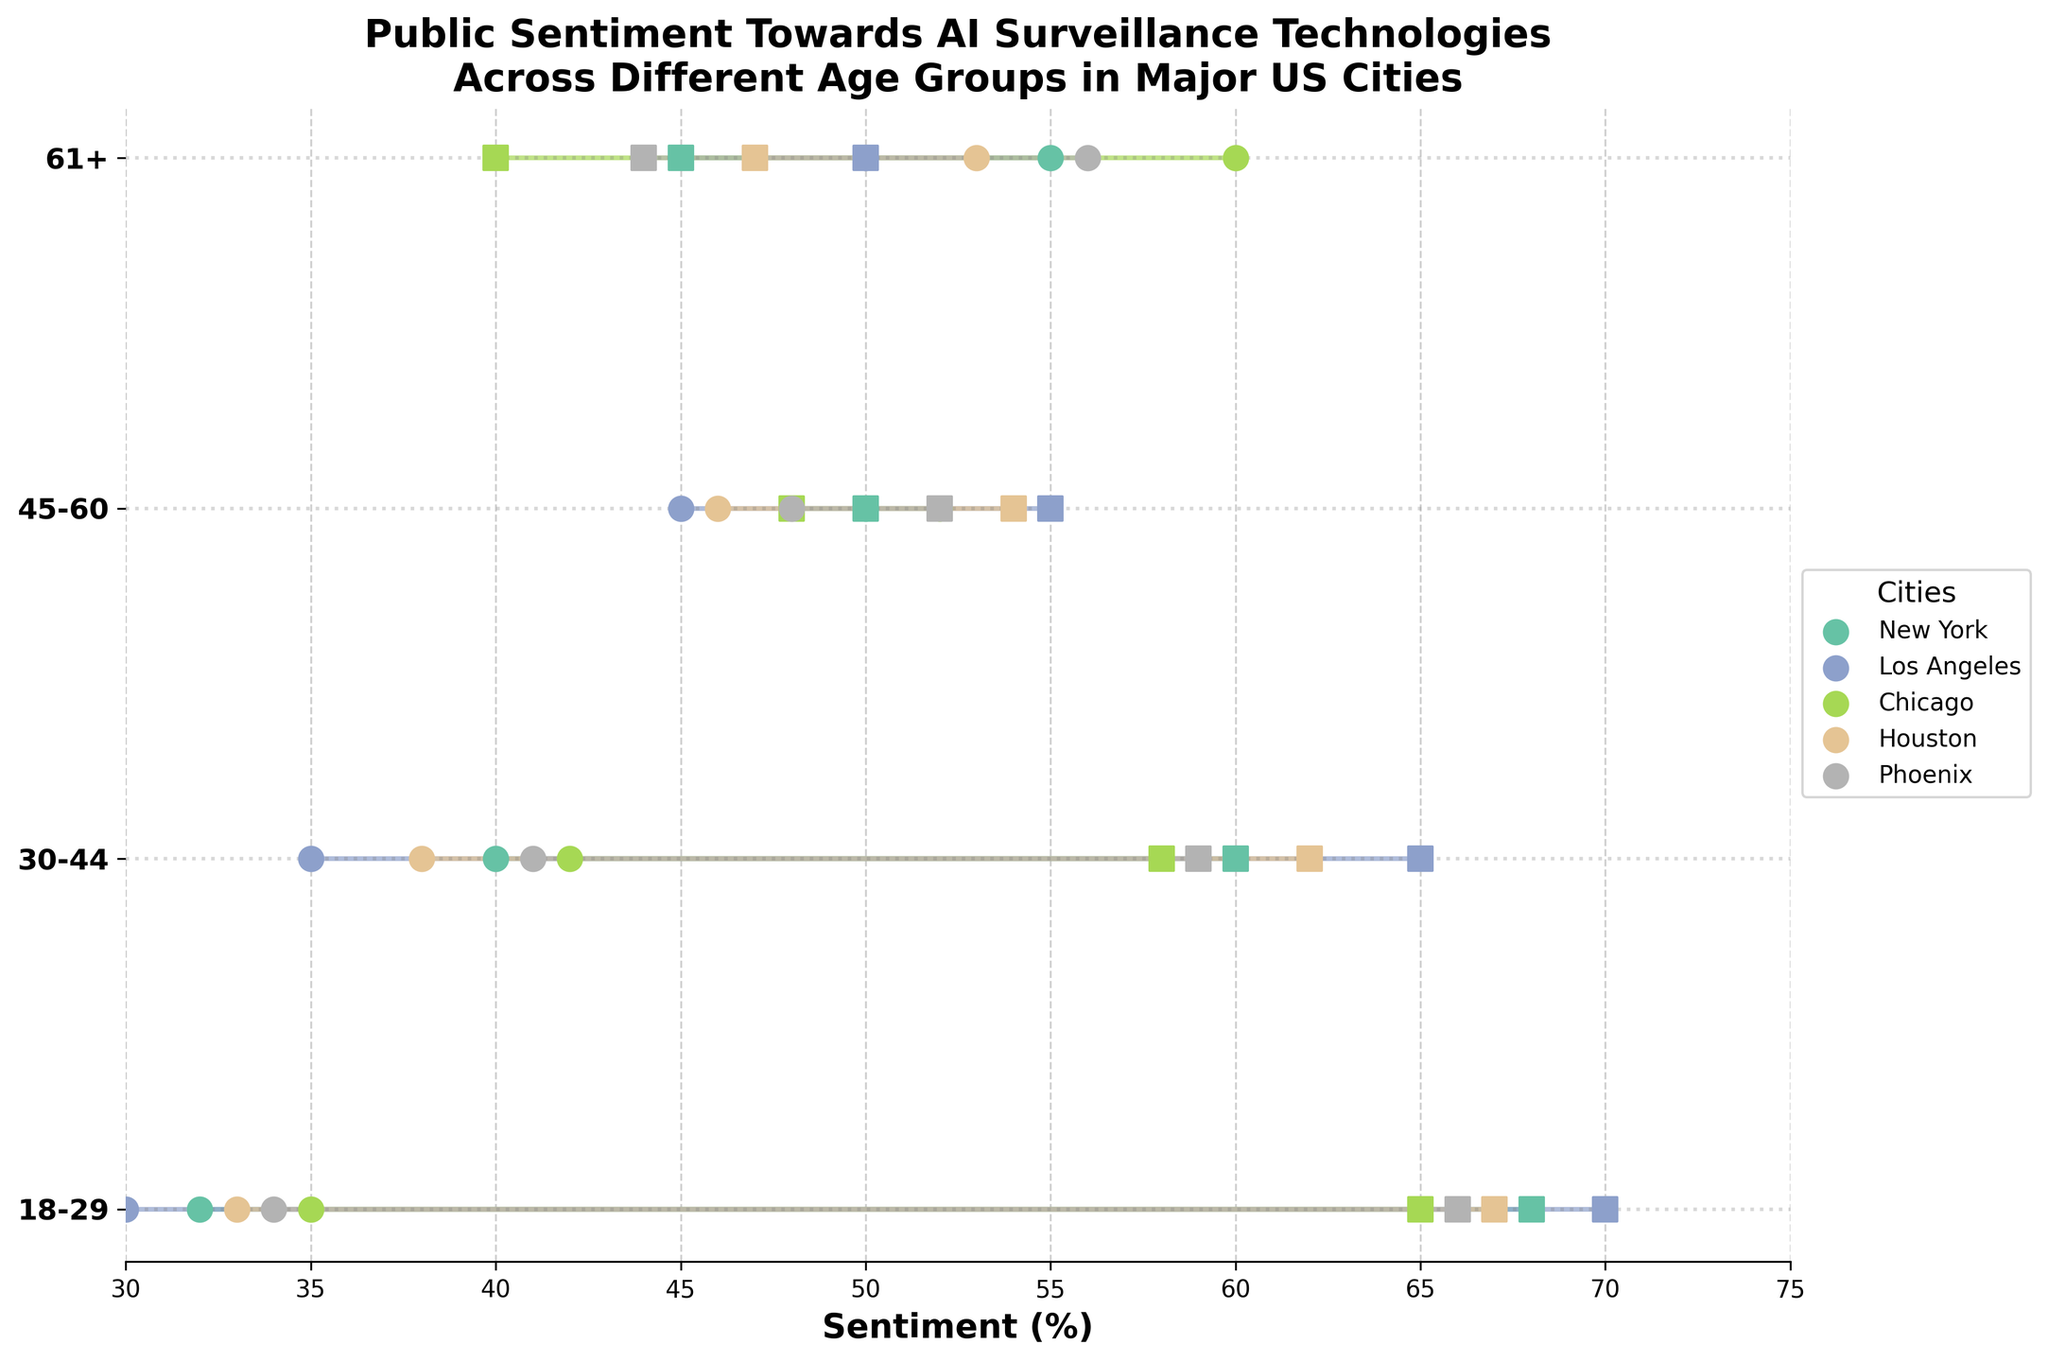What is the main title of the plot? The main title of the plot is typically displayed at the top of the figure. It is given in the provided code as "Public Sentiment Towards AI Surveillance Technologies Across Different Age Groups in Major US Cities".
Answer: Public Sentiment Towards AI Surveillance Technologies Across Different Age Groups in Major US Cities Which city shows the highest positive sentiment for the age group 18-29? To find the city with the highest positive sentiment for the age group 18-29, refer to the lines and markers plotted for this age group on the x-axis and note their positions. The highest positive sentiment value is 70, which corresponds to Los Angeles.
Answer: Los Angeles What is the overall trend of positive sentiment towards AI surveillance as age increases in New York? To observe the trend, look at the position of the markers for positive sentiment in New York across different age groups on the plot. Notice how the markers shift from left to right. In New York, the positive sentiment decreases as age increases, starting from 68 for the 18-29 group down to 45 for the 61+ group.
Answer: Decreases Which age group in Chicago shows an equal percentage of positive and negative sentiment? Look at the position of the markers in the Dumbbell Plot for Chicago for each age group. The age group with an equal percentage of positive and negative sentiment would have the markers at the same position on the 50% line. No age group in Chicago shows equal sentiment as all points lie either side of the 50% line.
Answer: None How does the positive sentiment in Phoenix for the age group 30-44 compare with the same age group in Houston? Compare the positions of the markers for positive sentiment for the age group 30-44 in Phoenix and Houston on the x-axis. Phoenix has a positive sentiment of 59%, while Houston has 62%. Hence, Phoenix is lower than Houston.
Answer: Phoenix is lower than Houston What is the difference in negative sentiment between the youngest and oldest age groups in Los Angeles? Locate the markers for negative sentiment in Los Angeles for the age groups 18-29 and 61+. The negative sentiment values are 30% and 50% respectively. Subtract the former from the latter: 50 - 30 = 20.
Answer: 20 Which city has the highest negative sentiment for the age group 61+? Refer to the position of the markers on the plot for the negative sentiment of the age group 61+ across all cities plotted on the x-axis. The highest negative sentiment value for this age group is 60%, which corresponds to Chicago.
Answer: Chicago What is the average positive sentiment for the age group 45-60 across all cities? To find the average, add positive sentiment values for the age group 45-60 across all cities: New York (50), Los Angeles (55), Chicago (48), Houston (54), and Phoenix (52). Sum them up: 50 + 55 + 48 + 54 + 52 = 259. Divide by 5, the number of cities: 259/5 = 51.8.
Answer: 51.8 How do sentiments vary between the cities for the age group 18-29? Observe the markers for the age group 18-29 across all cities, noting the positive and negative sentiment percentages. New York (68% positive, 32% negative), Los Angeles (70% positive, 30% negative), Chicago (65% positive, 35% negative), Houston (67% positive, 33% negative), and Phoenix (66% positive, 34% negative).
Answer: Positive and negative sentiments vary, with Los Angeles having the highest positive sentiment and others closely following 